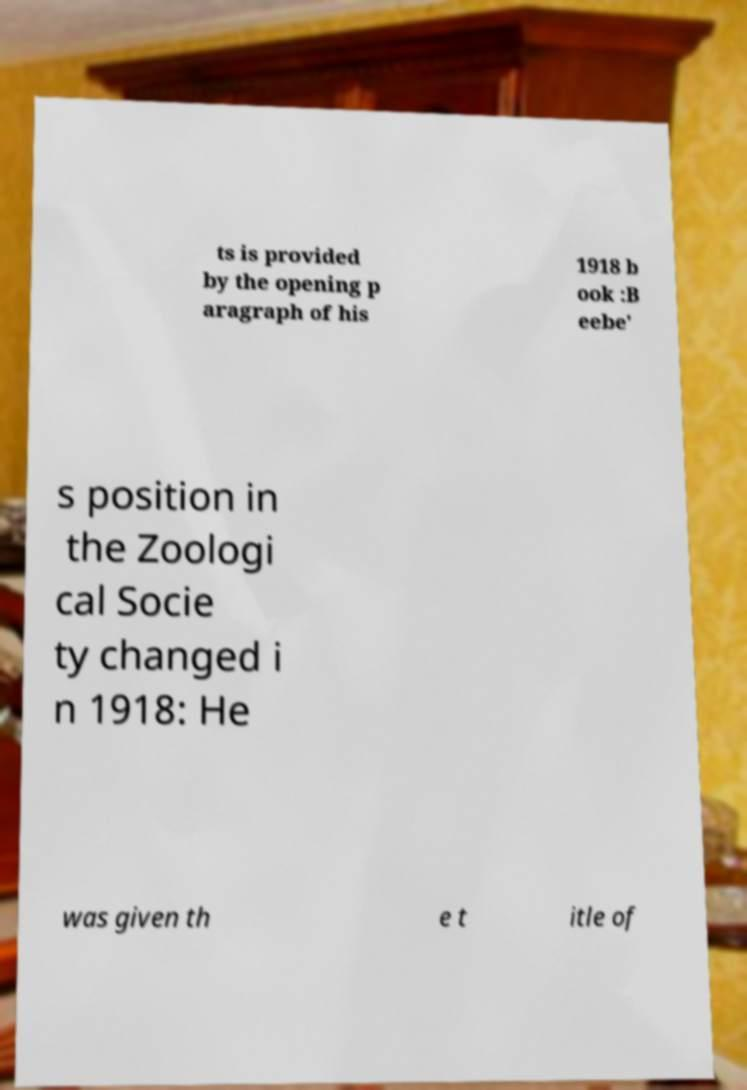I need the written content from this picture converted into text. Can you do that? ts is provided by the opening p aragraph of his 1918 b ook :B eebe' s position in the Zoologi cal Socie ty changed i n 1918: He was given th e t itle of 